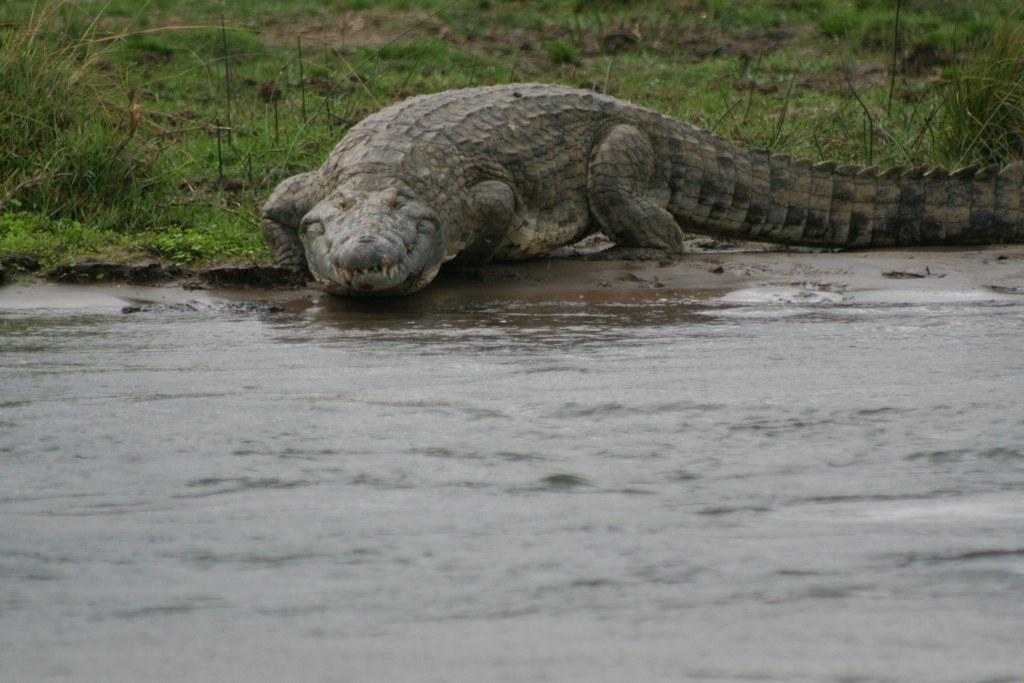What animal is in the water in the image? There is a crocodile in the water in the image. What can be seen in the background of the image? The ground is visible in the background of the image. What type of advertisement is displayed on the leaf in the image? There is no leaf or advertisement present in the image. What color is the orange in the image? There is no orange present in the image. 